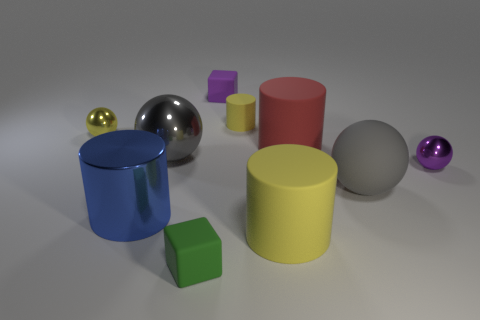Subtract all balls. How many objects are left? 6 Add 1 big red matte things. How many big red matte things exist? 2 Subtract 0 cyan cylinders. How many objects are left? 10 Subtract all tiny yellow cylinders. Subtract all small purple shiny spheres. How many objects are left? 8 Add 8 purple metal objects. How many purple metal objects are left? 9 